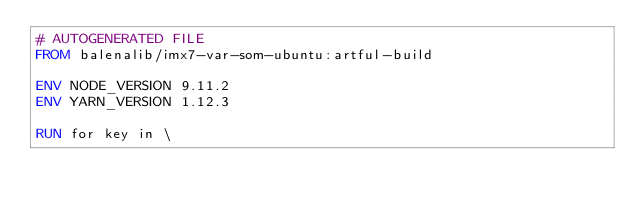<code> <loc_0><loc_0><loc_500><loc_500><_Dockerfile_># AUTOGENERATED FILE
FROM balenalib/imx7-var-som-ubuntu:artful-build

ENV NODE_VERSION 9.11.2
ENV YARN_VERSION 1.12.3

RUN for key in \</code> 